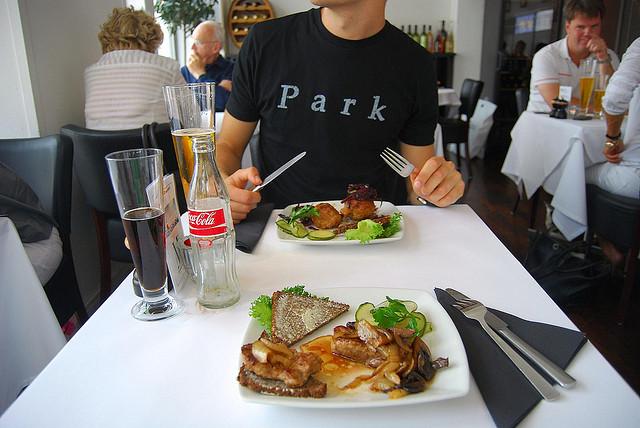What does the quality of the food look like?
Concise answer only. Good. What is likely in the drinking glass on the close left?
Give a very brief answer. Coke. What word is on his shirt?
Answer briefly. Park. 